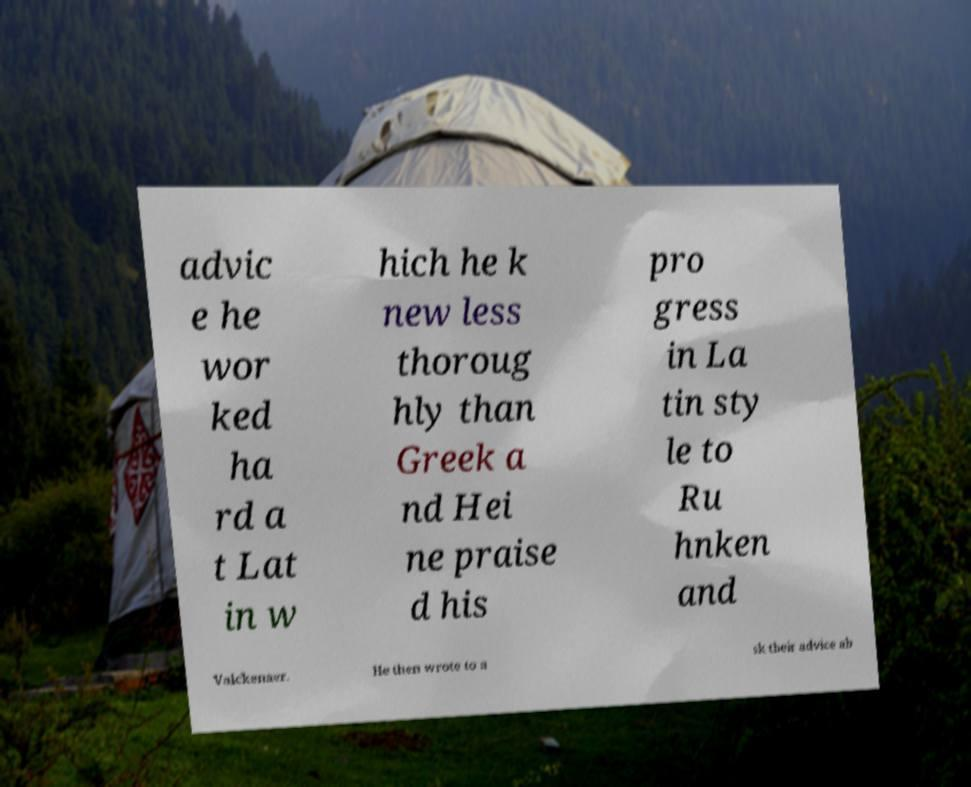What messages or text are displayed in this image? I need them in a readable, typed format. advic e he wor ked ha rd a t Lat in w hich he k new less thoroug hly than Greek a nd Hei ne praise d his pro gress in La tin sty le to Ru hnken and Valckenaer. He then wrote to a sk their advice ab 